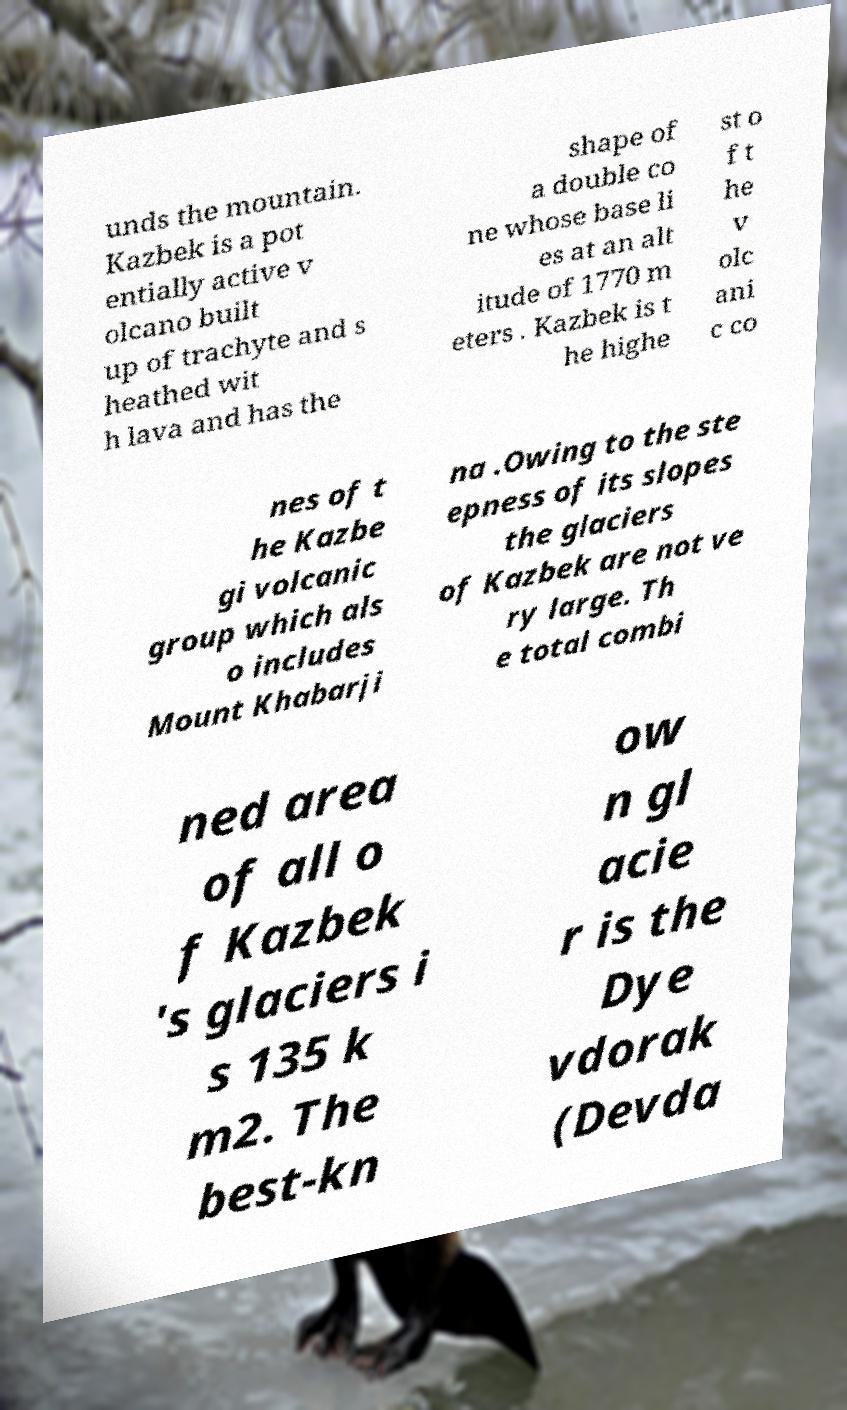What messages or text are displayed in this image? I need them in a readable, typed format. unds the mountain. Kazbek is a pot entially active v olcano built up of trachyte and s heathed wit h lava and has the shape of a double co ne whose base li es at an alt itude of 1770 m eters . Kazbek is t he highe st o f t he v olc ani c co nes of t he Kazbe gi volcanic group which als o includes Mount Khabarji na .Owing to the ste epness of its slopes the glaciers of Kazbek are not ve ry large. Th e total combi ned area of all o f Kazbek 's glaciers i s 135 k m2. The best-kn ow n gl acie r is the Dye vdorak (Devda 